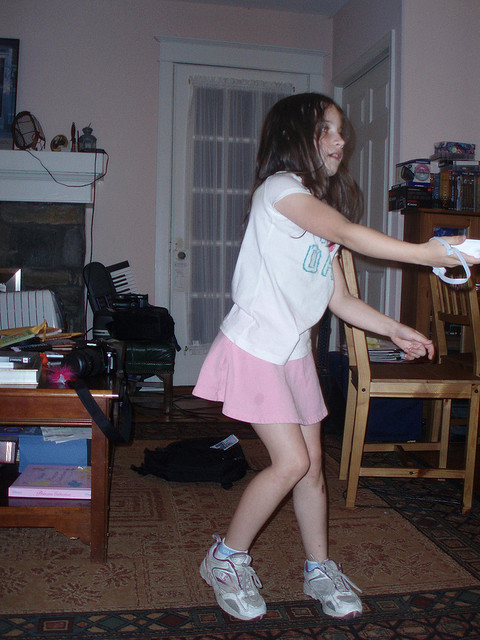Please transcribe the text information in this image. OH 